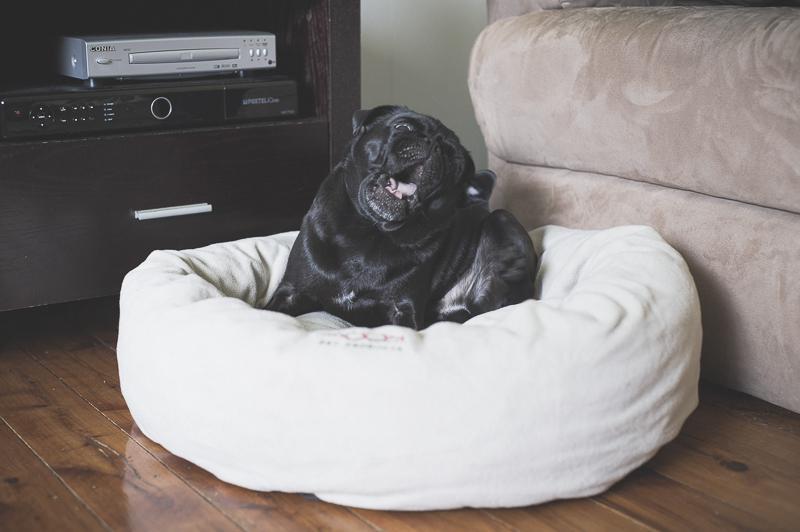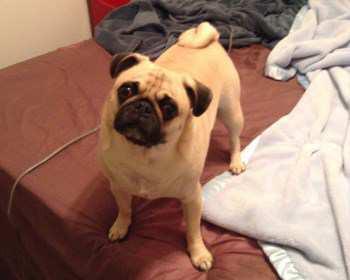The first image is the image on the left, the second image is the image on the right. Examine the images to the left and right. Is the description "The combined images include two pugs who are sleeping in a plush round pet bed." accurate? Answer yes or no. No. The first image is the image on the left, the second image is the image on the right. Examine the images to the left and right. Is the description "The left and right image contains the same number of tan pugs resting on their bed." accurate? Answer yes or no. No. 